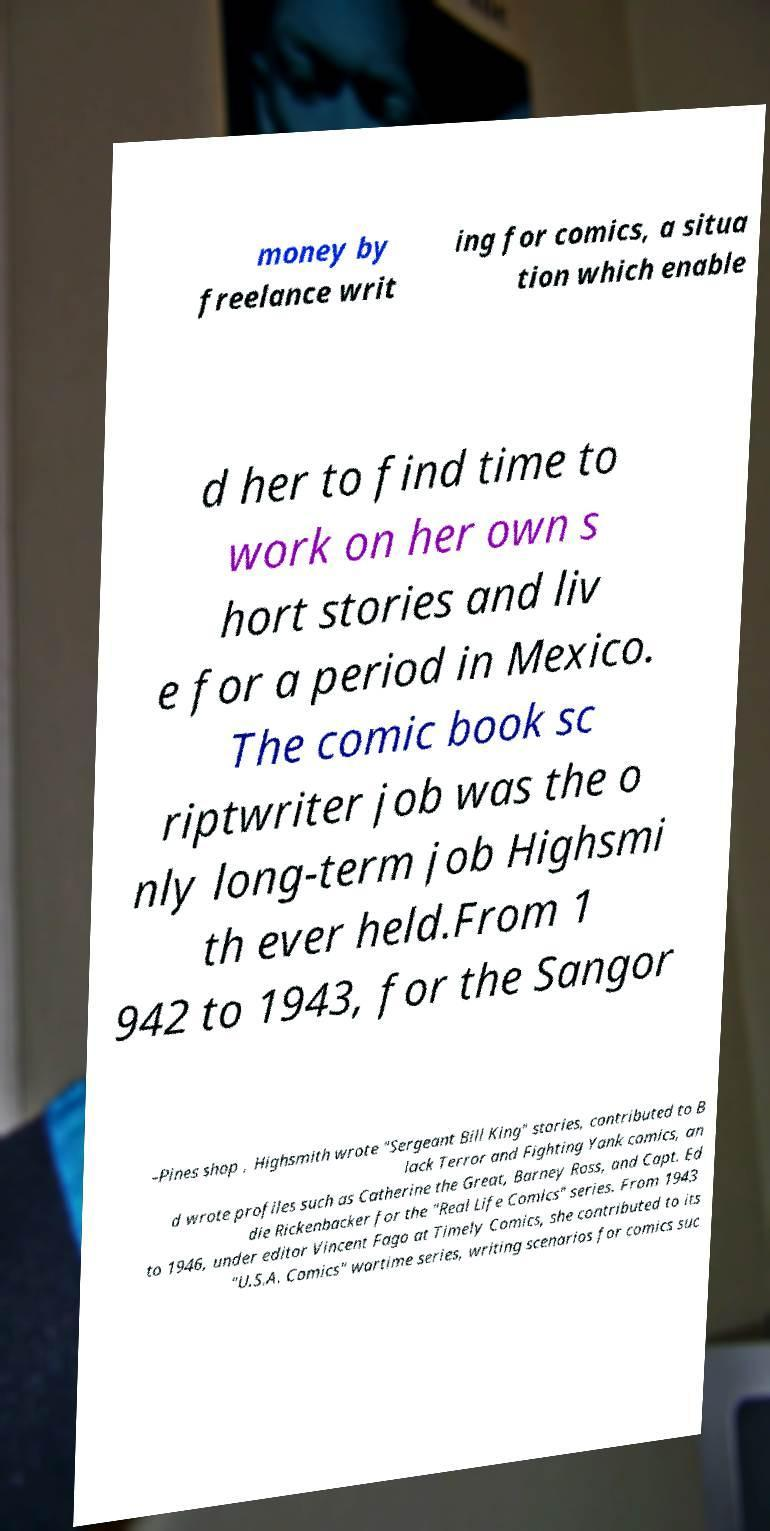There's text embedded in this image that I need extracted. Can you transcribe it verbatim? money by freelance writ ing for comics, a situa tion which enable d her to find time to work on her own s hort stories and liv e for a period in Mexico. The comic book sc riptwriter job was the o nly long-term job Highsmi th ever held.From 1 942 to 1943, for the Sangor –Pines shop , Highsmith wrote "Sergeant Bill King" stories, contributed to B lack Terror and Fighting Yank comics, an d wrote profiles such as Catherine the Great, Barney Ross, and Capt. Ed die Rickenbacker for the "Real Life Comics" series. From 1943 to 1946, under editor Vincent Fago at Timely Comics, she contributed to its "U.S.A. Comics" wartime series, writing scenarios for comics suc 